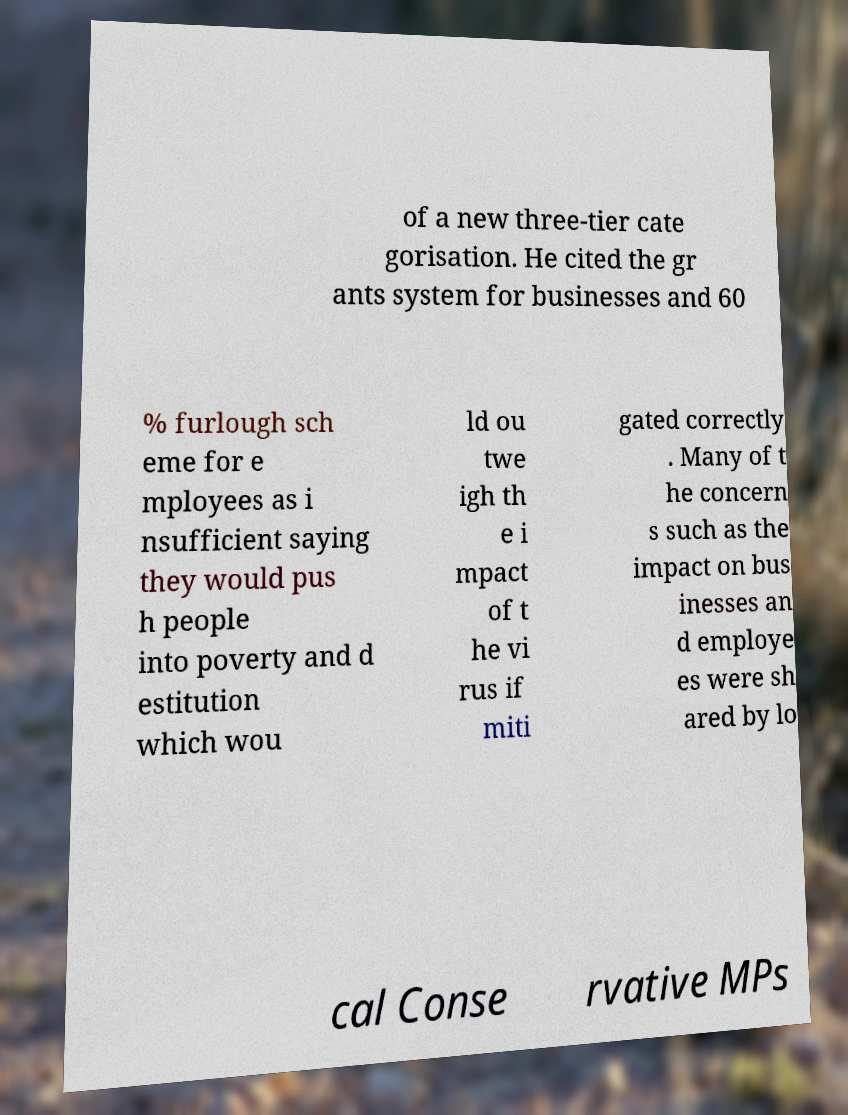Could you assist in decoding the text presented in this image and type it out clearly? of a new three-tier cate gorisation. He cited the gr ants system for businesses and 60 % furlough sch eme for e mployees as i nsufficient saying they would pus h people into poverty and d estitution which wou ld ou twe igh th e i mpact of t he vi rus if miti gated correctly . Many of t he concern s such as the impact on bus inesses an d employe es were sh ared by lo cal Conse rvative MPs 